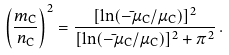<formula> <loc_0><loc_0><loc_500><loc_500>\left ( \frac { m _ { \text  C}}{n_{\text  C}}\right)^{2} = \frac{[\ln (-\bar{ }\mu_{\text  C}/\mu_{\text  C})]^{2}}     {[\ln (-\bar{ }\mu_{\text  C}/\mu_{\text  C})]^{2} + \pi^{2}} \, .</formula> 